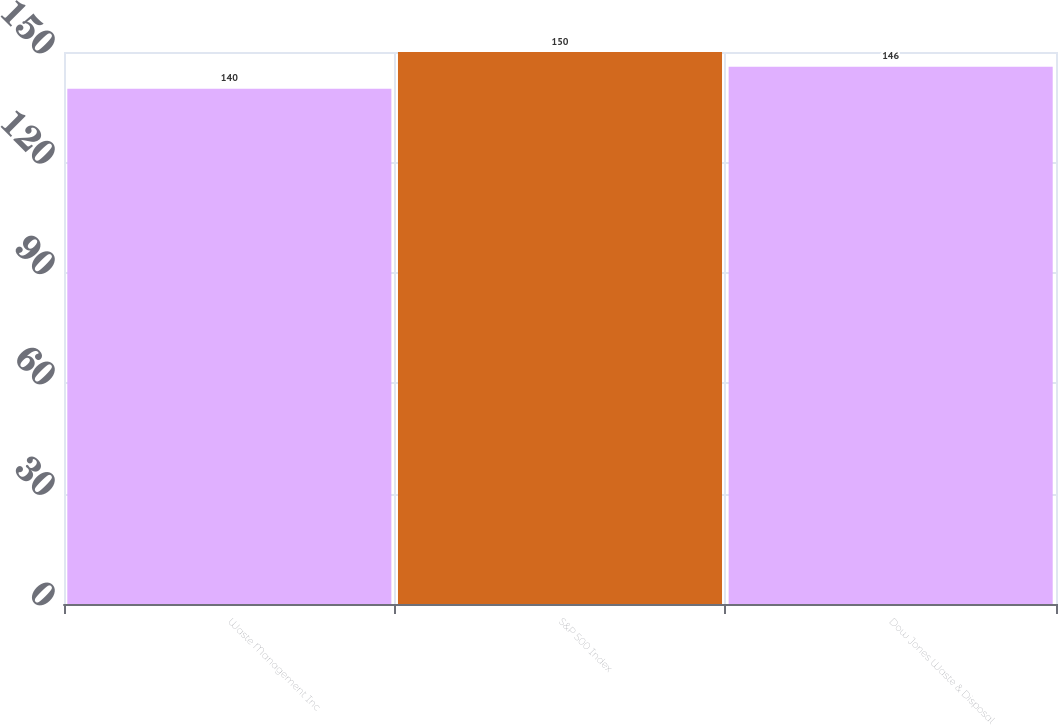Convert chart to OTSL. <chart><loc_0><loc_0><loc_500><loc_500><bar_chart><fcel>Waste Management Inc<fcel>S&P 500 Index<fcel>Dow Jones Waste & Disposal<nl><fcel>140<fcel>150<fcel>146<nl></chart> 